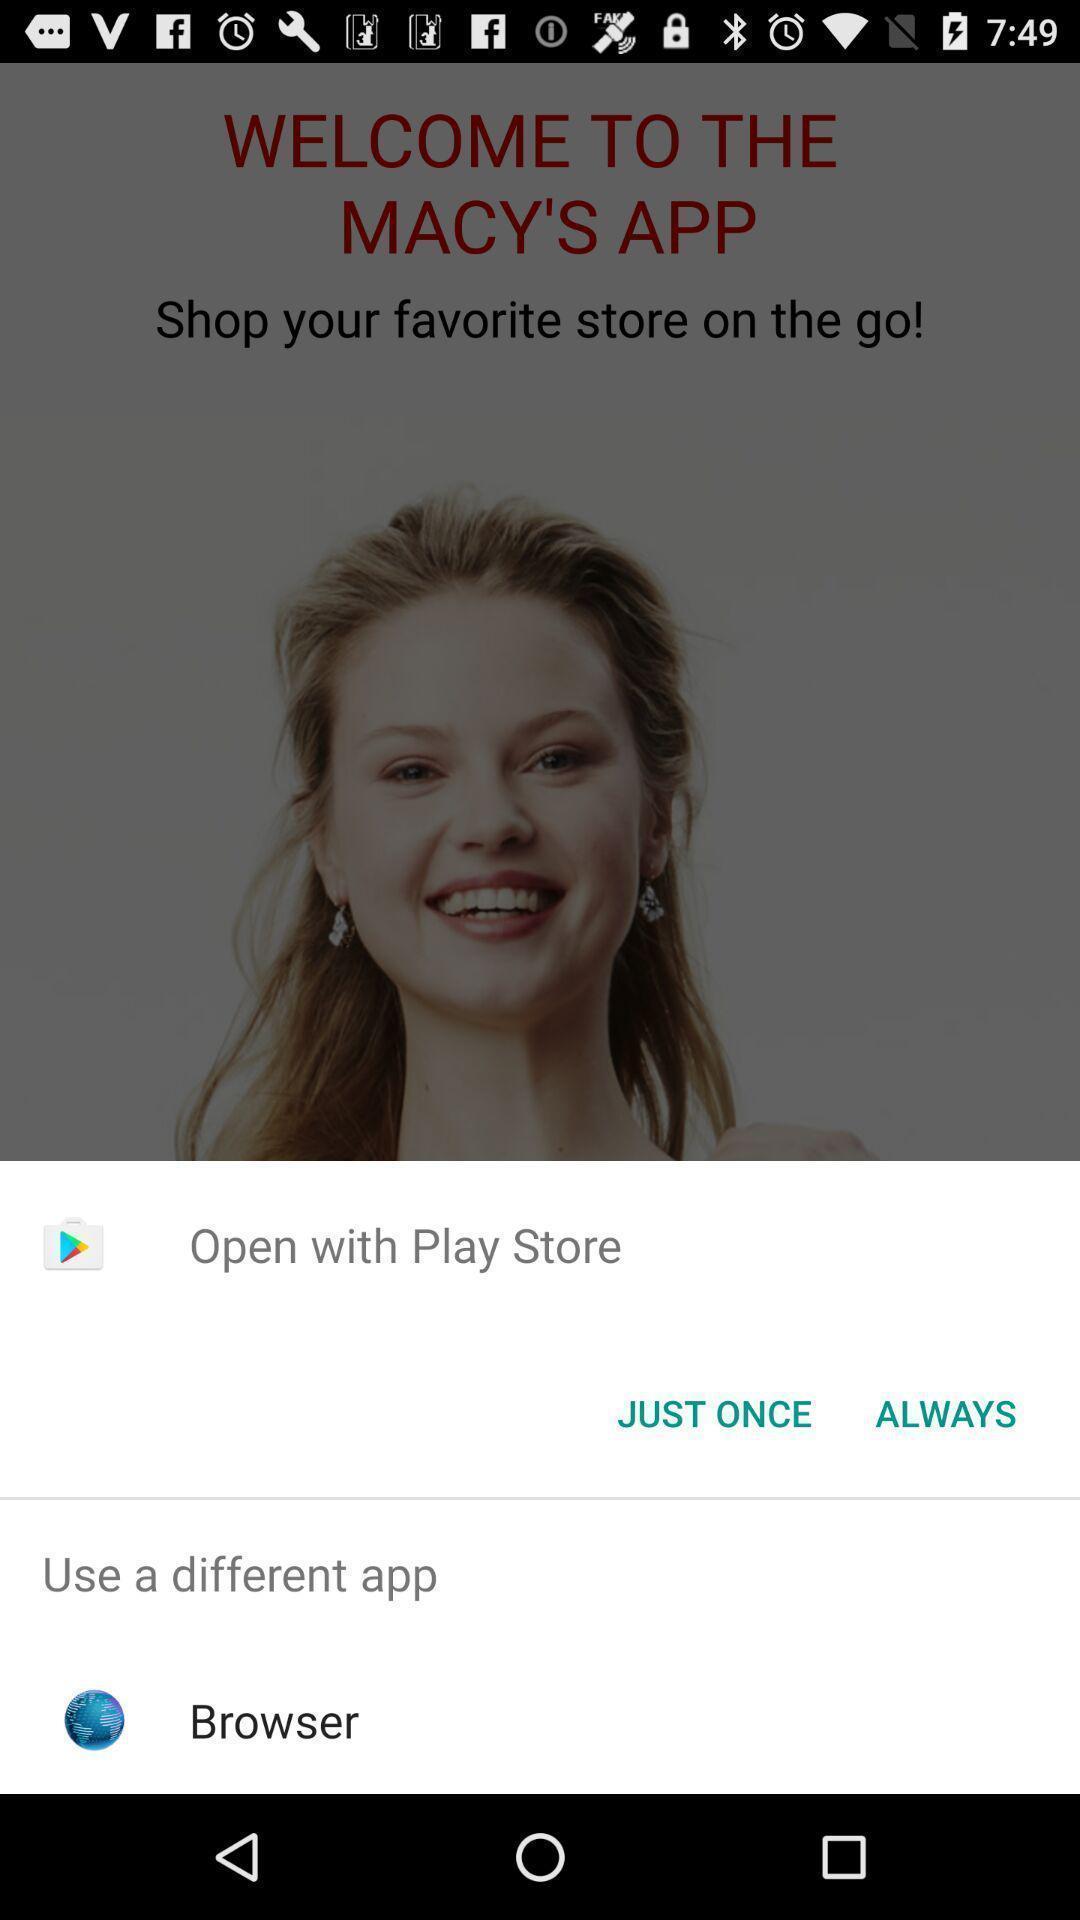Tell me about the visual elements in this screen capture. Popup showing about different apps options. 